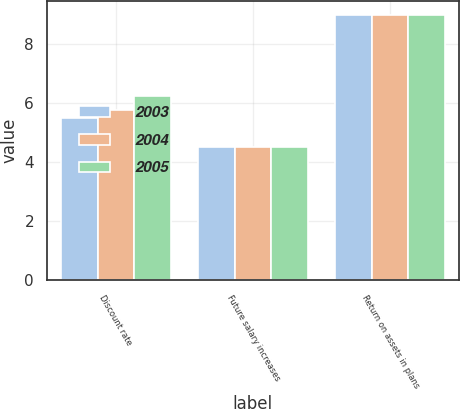Convert chart to OTSL. <chart><loc_0><loc_0><loc_500><loc_500><stacked_bar_chart><ecel><fcel>Discount rate<fcel>Future salary increases<fcel>Return on assets in plans<nl><fcel>2003<fcel>5.5<fcel>4.5<fcel>9<nl><fcel>2004<fcel>5.75<fcel>4.5<fcel>9<nl><fcel>2005<fcel>6.25<fcel>4.5<fcel>9<nl></chart> 